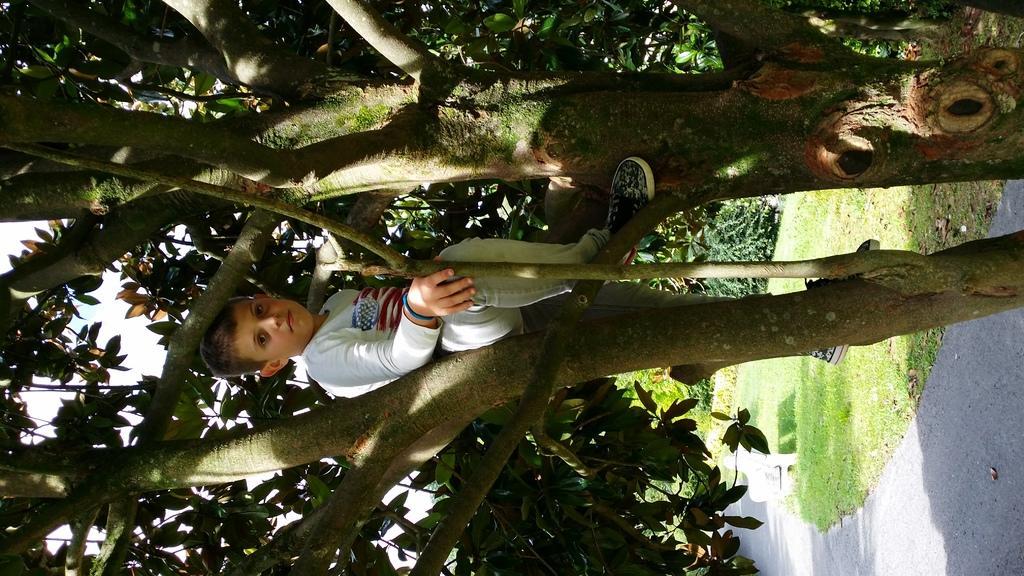Can you describe this image briefly? In the center of the image we can see a boy sitting on the tree. At the bottom there is grass and we can see a walkway. 